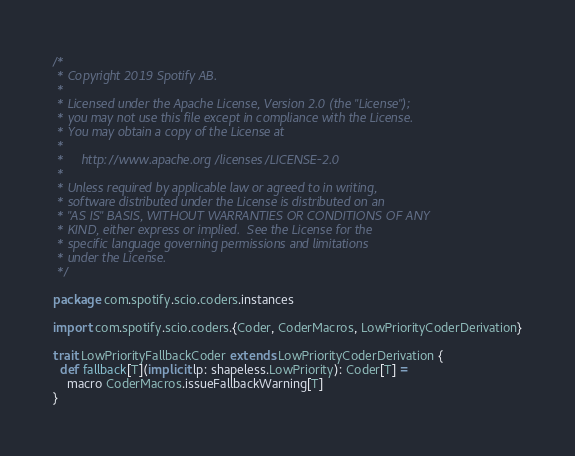<code> <loc_0><loc_0><loc_500><loc_500><_Scala_>/*
 * Copyright 2019 Spotify AB.
 *
 * Licensed under the Apache License, Version 2.0 (the "License");
 * you may not use this file except in compliance with the License.
 * You may obtain a copy of the License at
 *
 *     http://www.apache.org/licenses/LICENSE-2.0
 *
 * Unless required by applicable law or agreed to in writing,
 * software distributed under the License is distributed on an
 * "AS IS" BASIS, WITHOUT WARRANTIES OR CONDITIONS OF ANY
 * KIND, either express or implied.  See the License for the
 * specific language governing permissions and limitations
 * under the License.
 */

package com.spotify.scio.coders.instances

import com.spotify.scio.coders.{Coder, CoderMacros, LowPriorityCoderDerivation}

trait LowPriorityFallbackCoder extends LowPriorityCoderDerivation {
  def fallback[T](implicit lp: shapeless.LowPriority): Coder[T] =
    macro CoderMacros.issueFallbackWarning[T]
}
</code> 